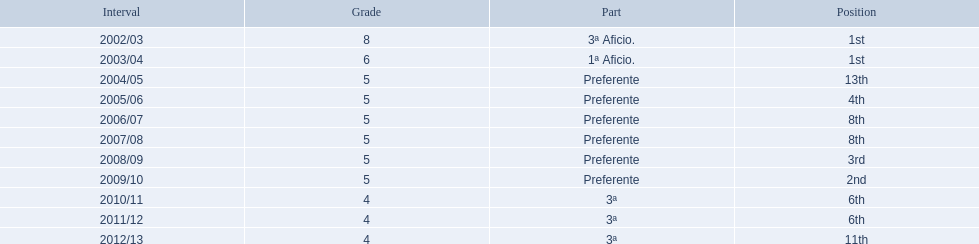How many times did  internacional de madrid cf come in 6th place? 6th, 6th. What is the first season that the team came in 6th place? 2010/11. Which season after the first did they place in 6th again? 2011/12. 